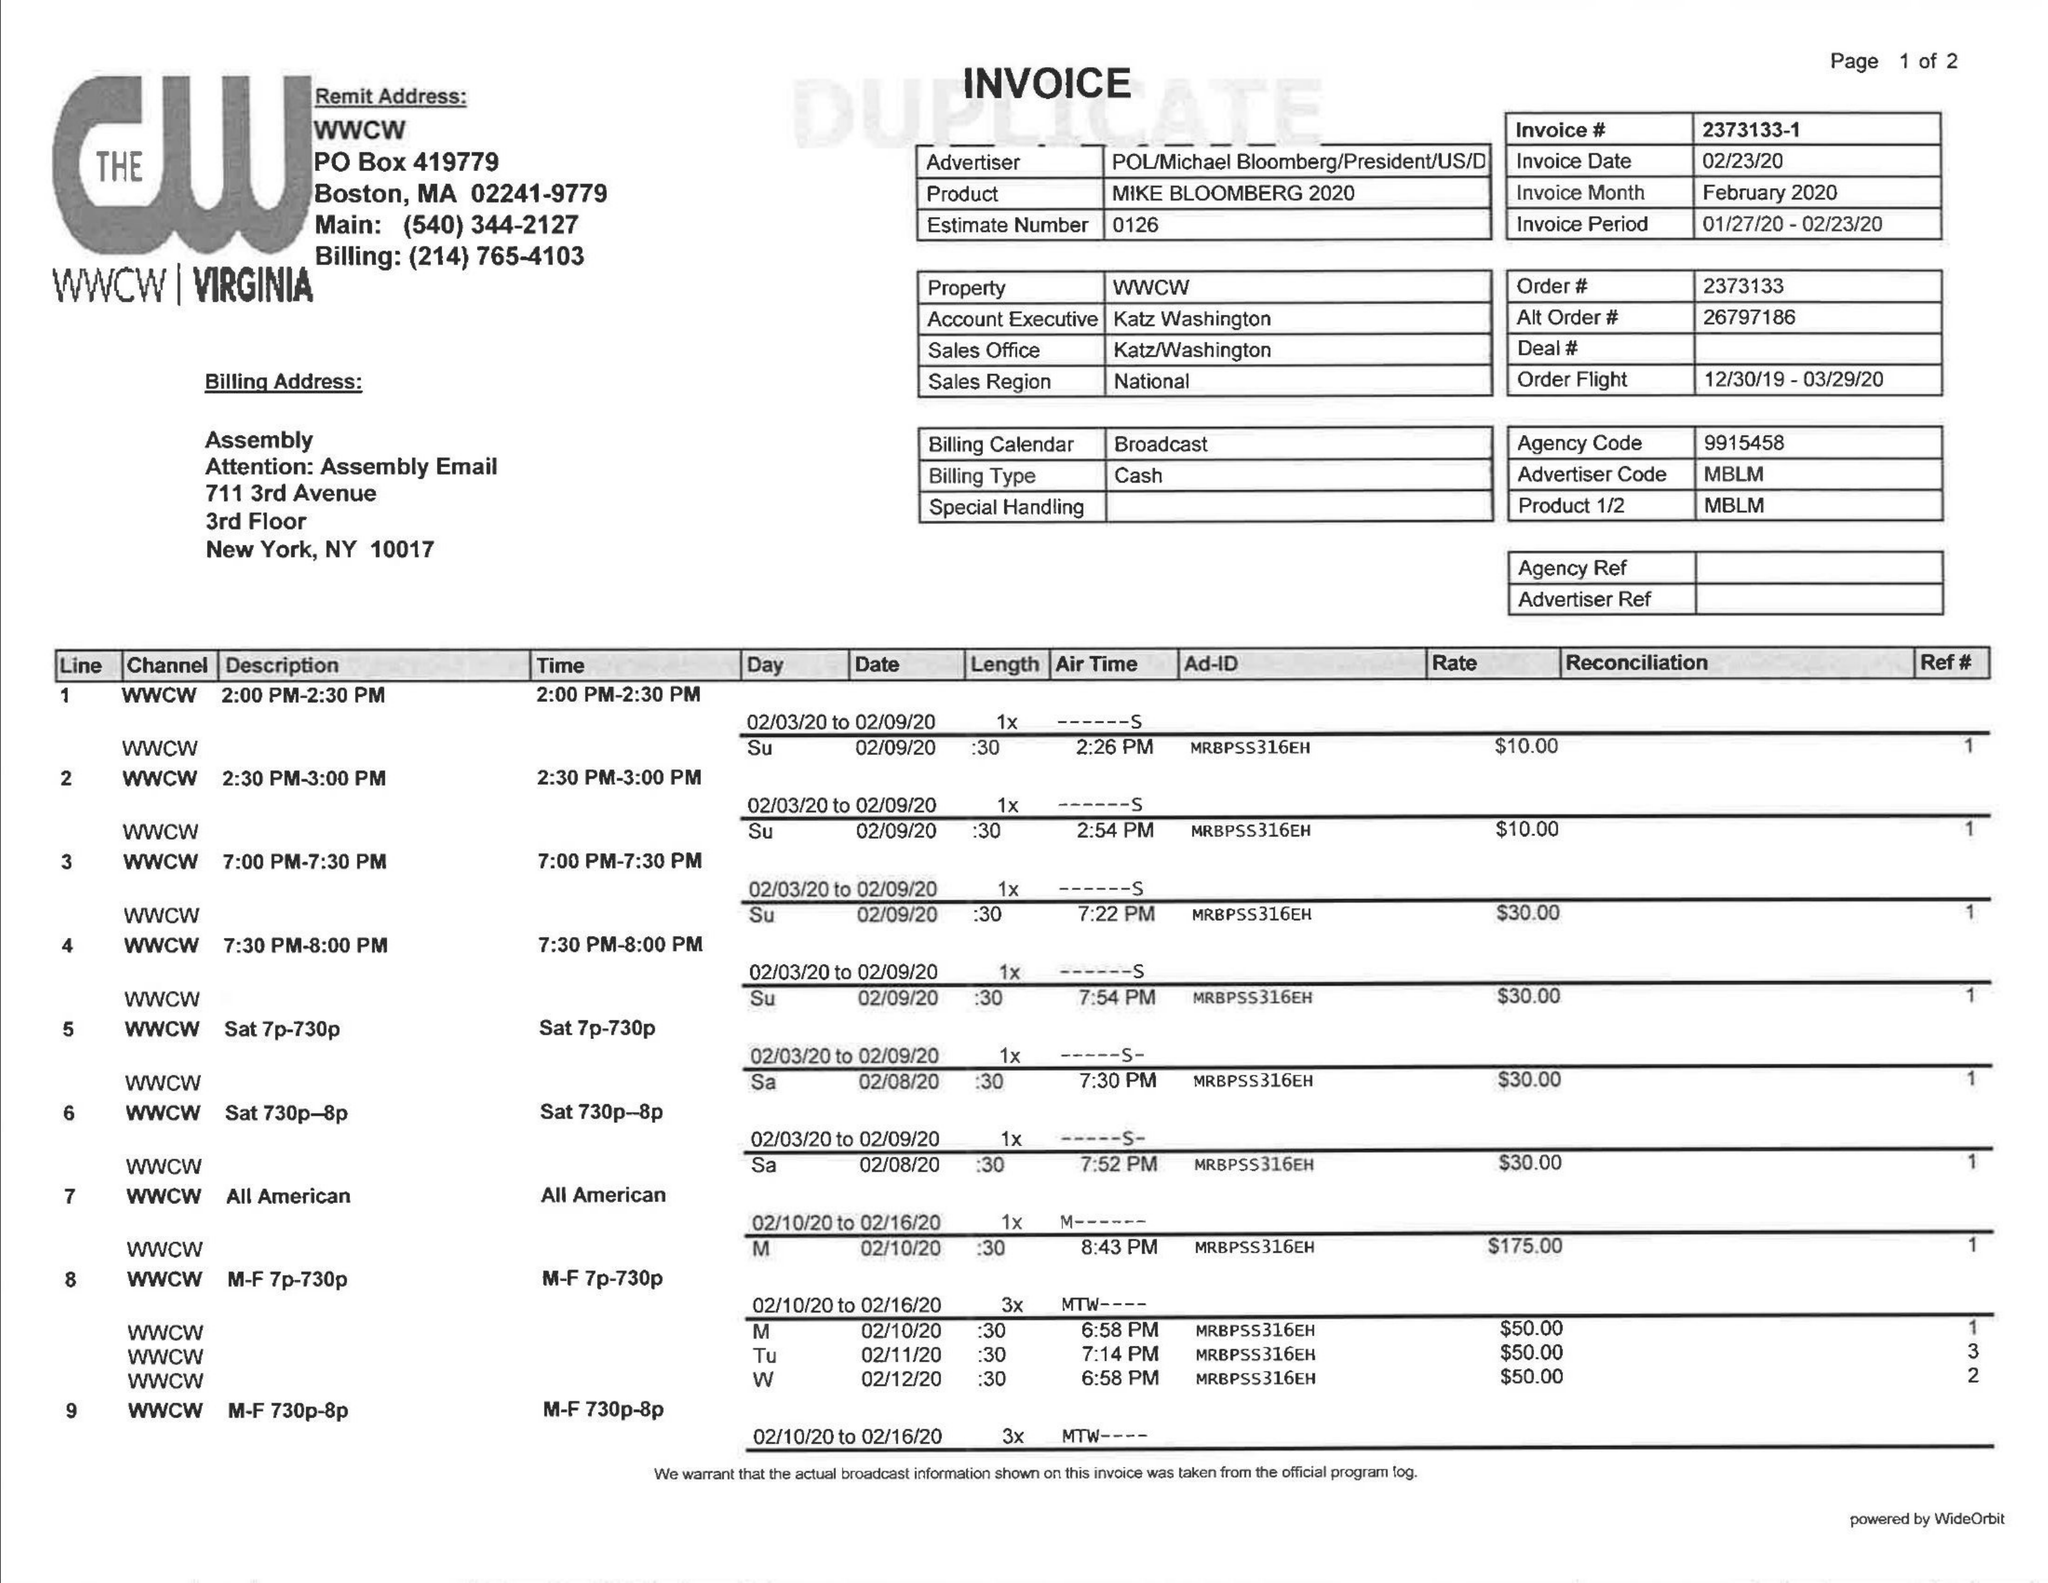What is the value for the flight_to?
Answer the question using a single word or phrase. 03/29/20 